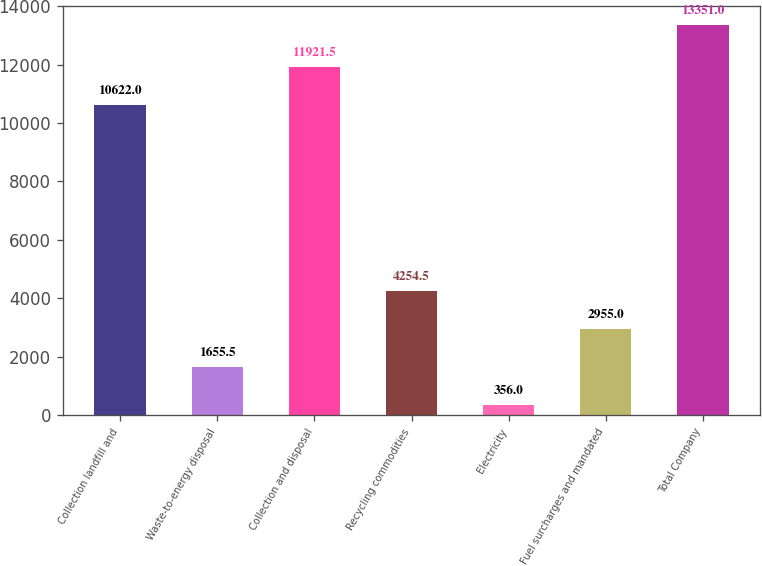<chart> <loc_0><loc_0><loc_500><loc_500><bar_chart><fcel>Collection landfill and<fcel>Waste-to-energy disposal<fcel>Collection and disposal<fcel>Recycling commodities<fcel>Electricity<fcel>Fuel surcharges and mandated<fcel>Total Company<nl><fcel>10622<fcel>1655.5<fcel>11921.5<fcel>4254.5<fcel>356<fcel>2955<fcel>13351<nl></chart> 